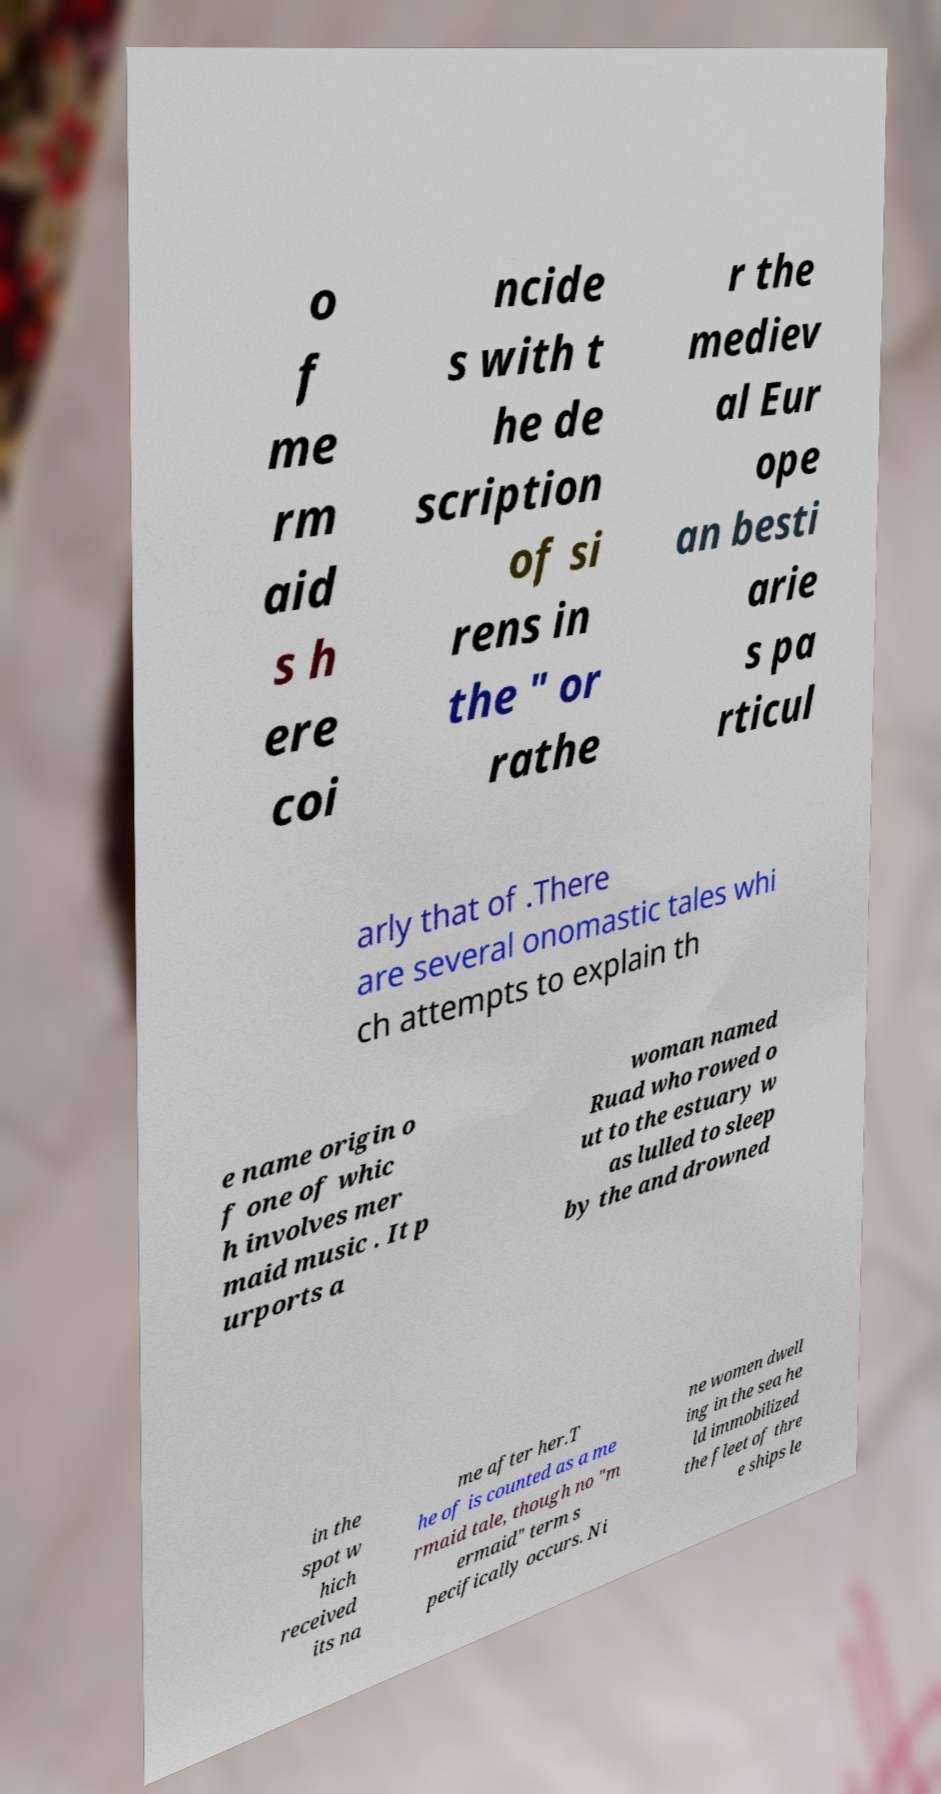Can you accurately transcribe the text from the provided image for me? o f me rm aid s h ere coi ncide s with t he de scription of si rens in the " or rathe r the mediev al Eur ope an besti arie s pa rticul arly that of .There are several onomastic tales whi ch attempts to explain th e name origin o f one of whic h involves mer maid music . It p urports a woman named Ruad who rowed o ut to the estuary w as lulled to sleep by the and drowned in the spot w hich received its na me after her.T he of is counted as a me rmaid tale, though no "m ermaid" term s pecifically occurs. Ni ne women dwell ing in the sea he ld immobilized the fleet of thre e ships le 